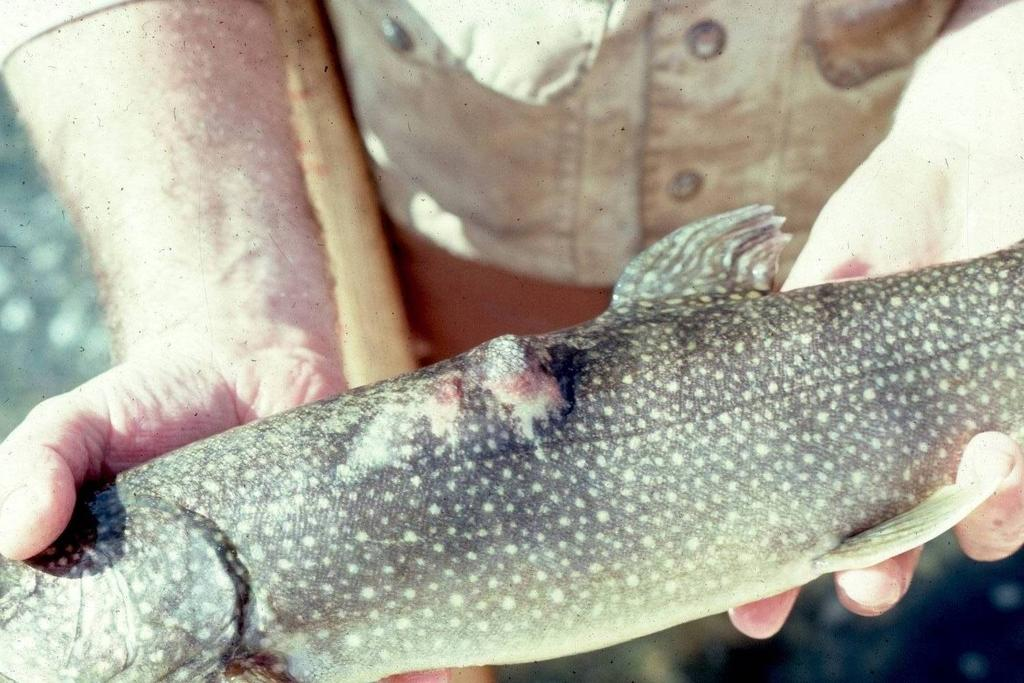Who is present in the image? There is a person in the image. What is the person holding in the image? The person is holding a fish. What type of wood is being used to cook the fish in the image? There is no wood or cooking activity present in the image; the person is simply holding a fish. 